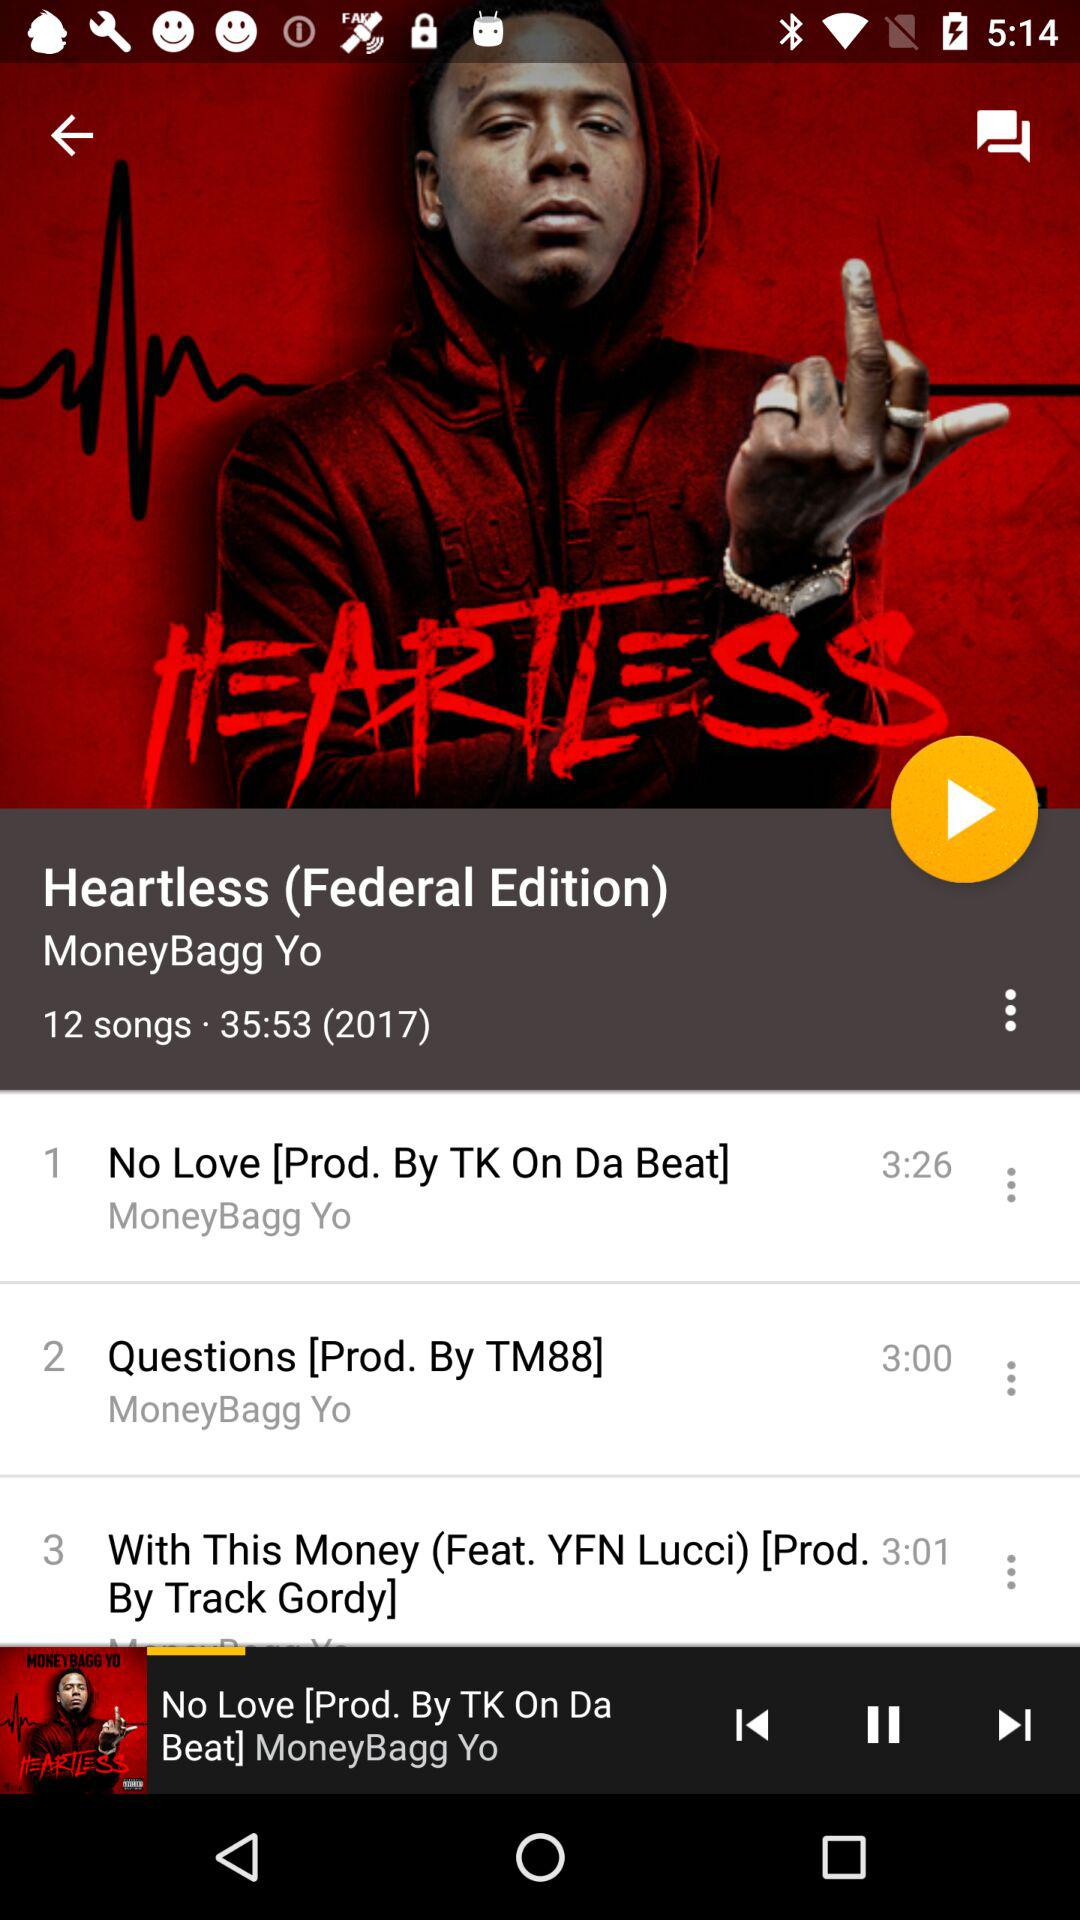What is the name of the rapper? The name of the rapper is MoneyBagg Yo. 